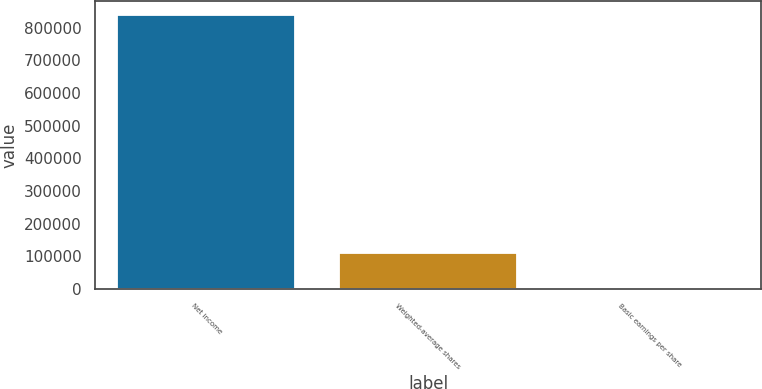Convert chart. <chart><loc_0><loc_0><loc_500><loc_500><bar_chart><fcel>Net income<fcel>Weighted-average shares<fcel>Basic earnings per share<nl><fcel>839189<fcel>111173<fcel>7.55<nl></chart> 